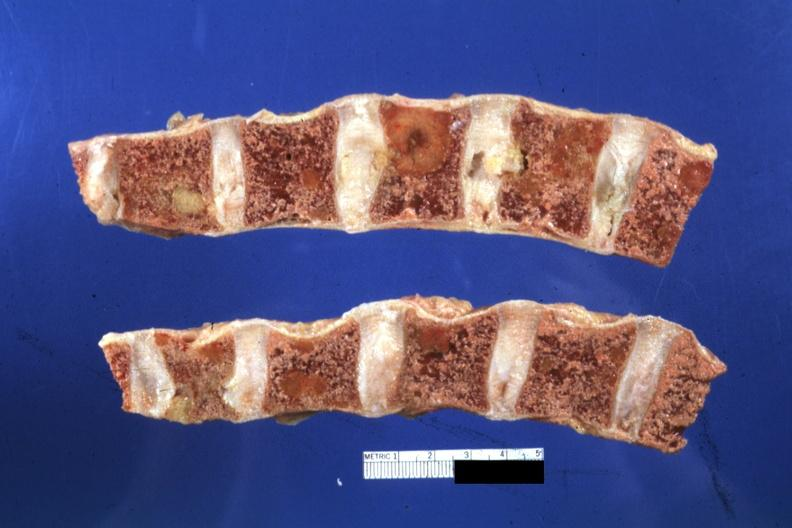does this image show appears fixed lesions show well?
Answer the question using a single word or phrase. Yes 